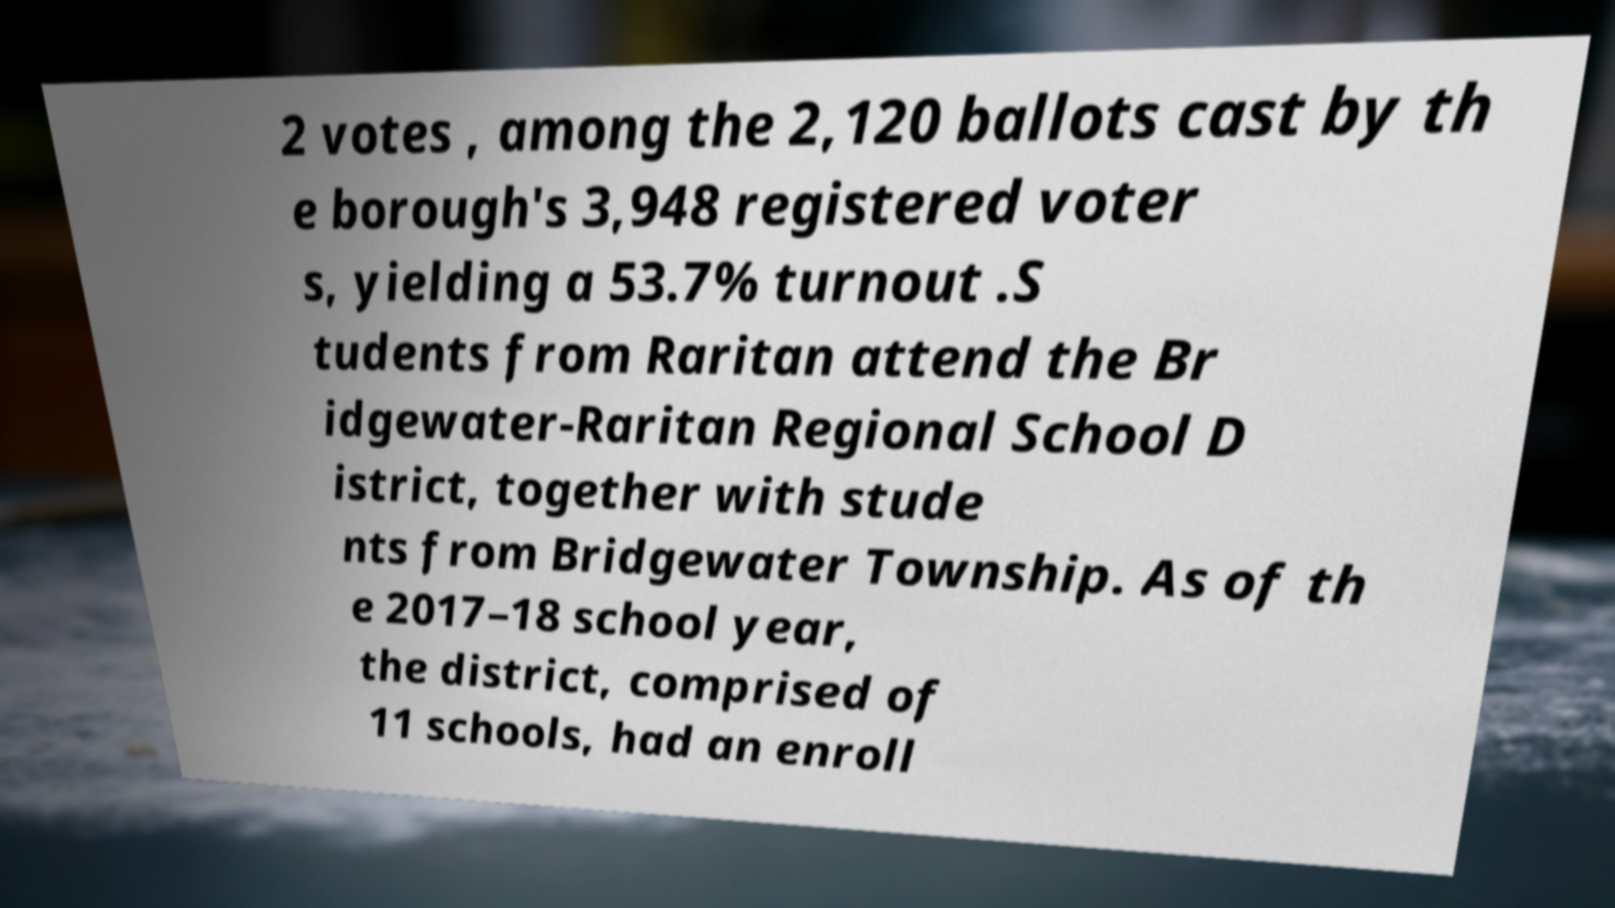Could you extract and type out the text from this image? 2 votes , among the 2,120 ballots cast by th e borough's 3,948 registered voter s, yielding a 53.7% turnout .S tudents from Raritan attend the Br idgewater-Raritan Regional School D istrict, together with stude nts from Bridgewater Township. As of th e 2017–18 school year, the district, comprised of 11 schools, had an enroll 